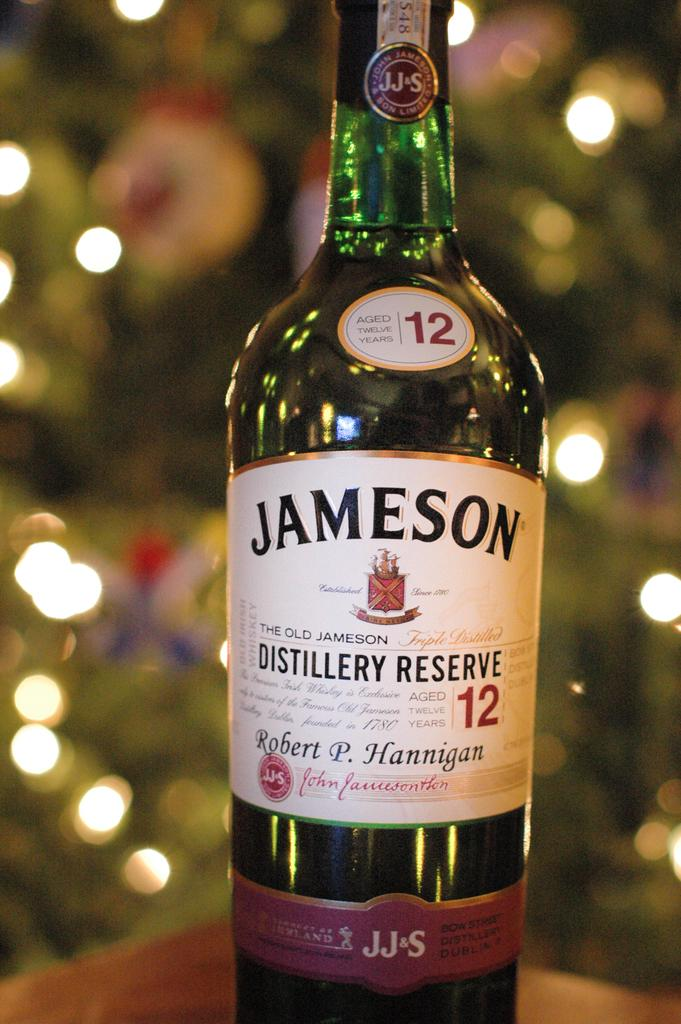<image>
Share a concise interpretation of the image provided. the word Jameson that is on a bottle 